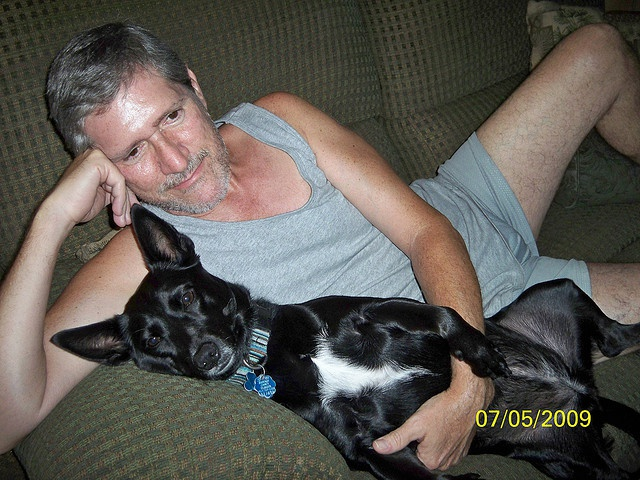Describe the objects in this image and their specific colors. I can see people in black, darkgray, and gray tones, couch in black and gray tones, and dog in black, gray, and lightgray tones in this image. 